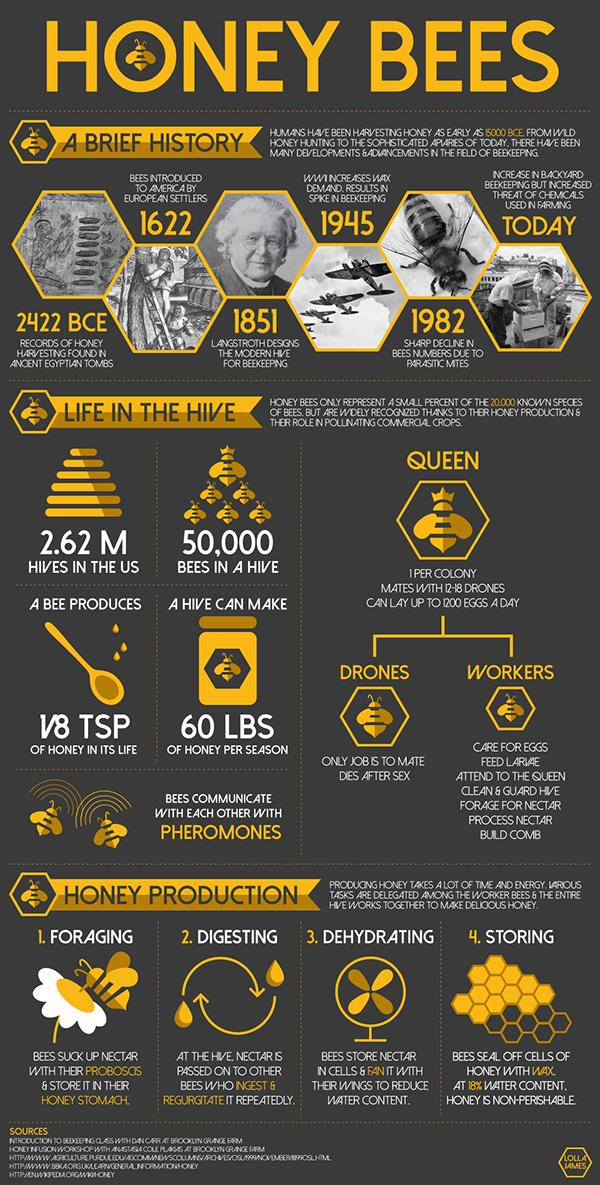List a handful of essential elements in this visual. A sharp decline in bee populations was observed in 1982, primarily due to the impact of parasitic mites. The records of honey harvesting in ancient Egyptian tombs were found to date back to 2422 BCE. A bee produces only 1/8 teaspoon of honey in its lifetime. In 1851, Langstroth designed the modern hive for beekeeping, which remains a widely used design to this day. In the United States, a total of 2,620,000 hives were discovered. 